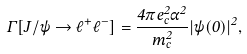Convert formula to latex. <formula><loc_0><loc_0><loc_500><loc_500>\Gamma [ J / \psi \to \ell ^ { + } \ell ^ { - } ] = \frac { 4 \pi e _ { c } ^ { 2 } \alpha ^ { 2 } } { m _ { c } ^ { 2 } } | \psi ( 0 ) | ^ { 2 } ,</formula> 